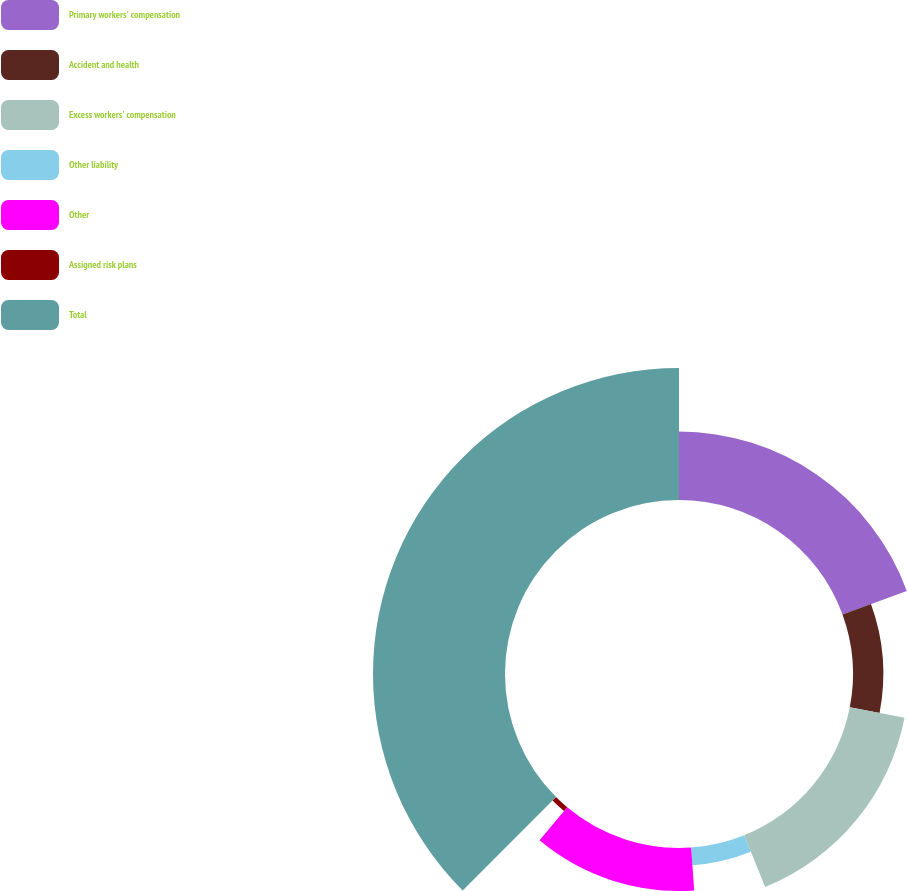Convert chart. <chart><loc_0><loc_0><loc_500><loc_500><pie_chart><fcel>Primary workers' compensation<fcel>Accident and health<fcel>Excess workers' compensation<fcel>Other liability<fcel>Other<fcel>Assigned risk plans<fcel>Total<nl><fcel>19.44%<fcel>8.61%<fcel>15.83%<fcel>5.0%<fcel>12.22%<fcel>1.39%<fcel>37.5%<nl></chart> 